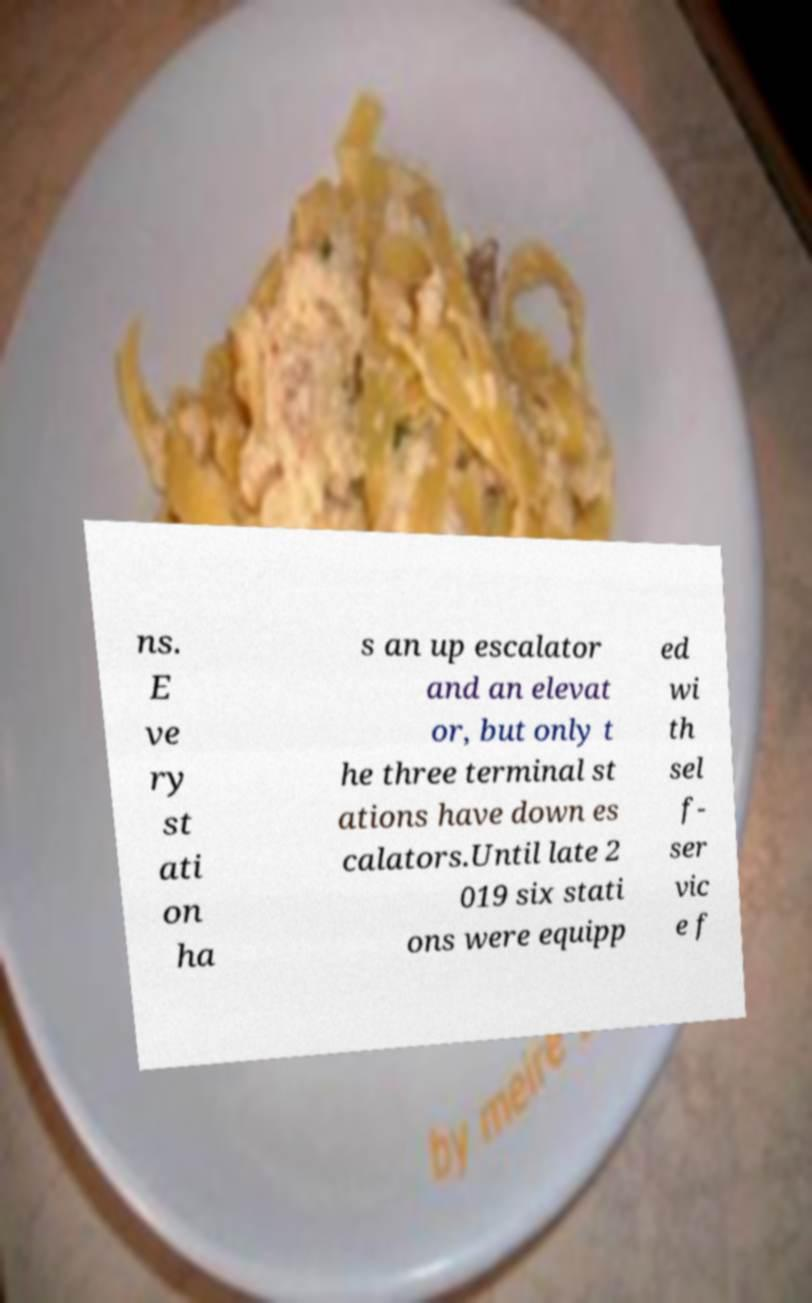For documentation purposes, I need the text within this image transcribed. Could you provide that? ns. E ve ry st ati on ha s an up escalator and an elevat or, but only t he three terminal st ations have down es calators.Until late 2 019 six stati ons were equipp ed wi th sel f- ser vic e f 